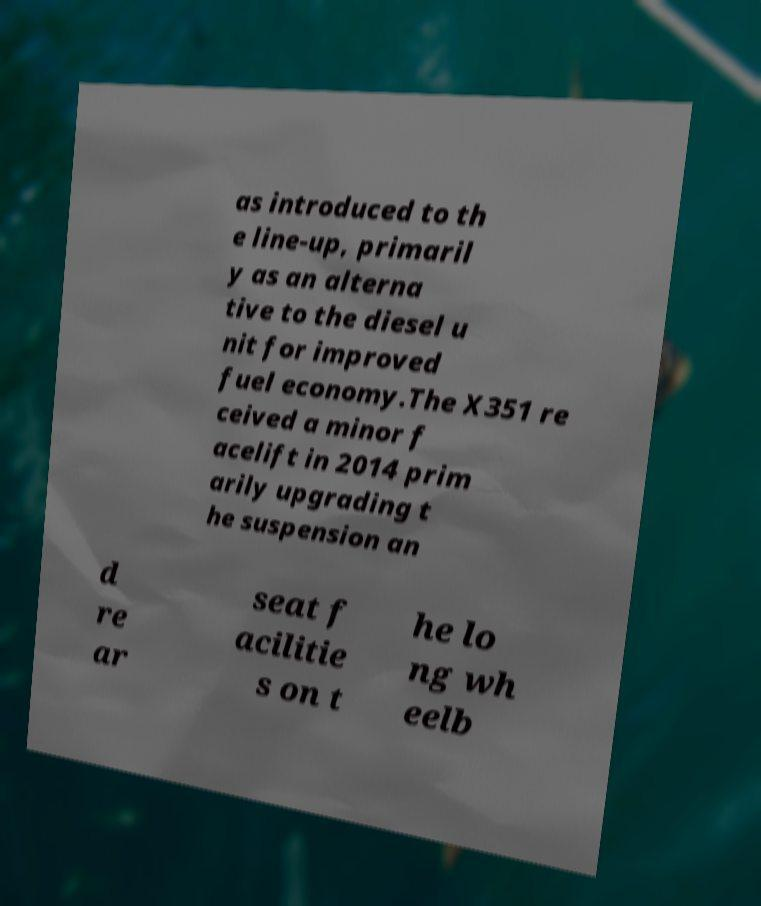There's text embedded in this image that I need extracted. Can you transcribe it verbatim? as introduced to th e line-up, primaril y as an alterna tive to the diesel u nit for improved fuel economy.The X351 re ceived a minor f acelift in 2014 prim arily upgrading t he suspension an d re ar seat f acilitie s on t he lo ng wh eelb 